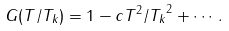<formula> <loc_0><loc_0><loc_500><loc_500>G ( T / T _ { k } ) = 1 - c T ^ { 2 } / { T _ { k } } ^ { 2 } + \cdots .</formula> 